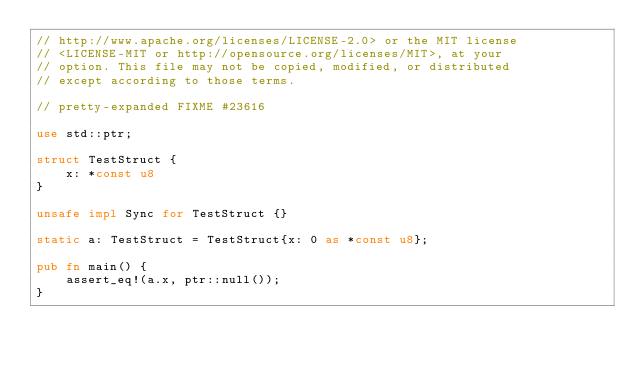Convert code to text. <code><loc_0><loc_0><loc_500><loc_500><_Rust_>// http://www.apache.org/licenses/LICENSE-2.0> or the MIT license
// <LICENSE-MIT or http://opensource.org/licenses/MIT>, at your
// option. This file may not be copied, modified, or distributed
// except according to those terms.

// pretty-expanded FIXME #23616

use std::ptr;

struct TestStruct {
    x: *const u8
}

unsafe impl Sync for TestStruct {}

static a: TestStruct = TestStruct{x: 0 as *const u8};

pub fn main() {
    assert_eq!(a.x, ptr::null());
}
</code> 